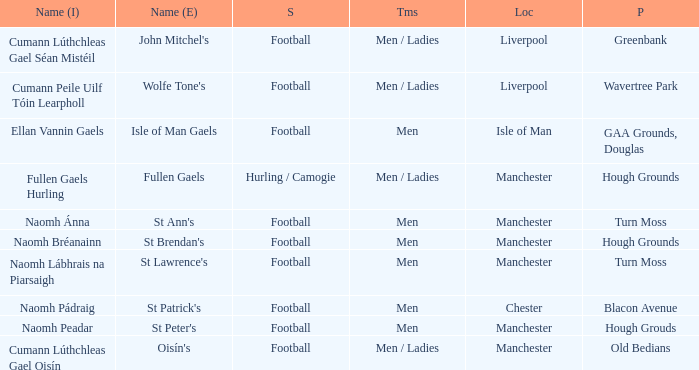What is the English Name of the Location in Chester? St Patrick's. 